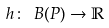Convert formula to latex. <formula><loc_0><loc_0><loc_500><loc_500>h \colon \ B ( P ) \to \mathbb { R }</formula> 